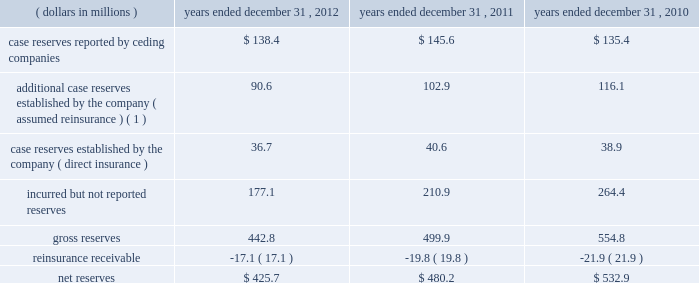The company endeavors to actively engage with every insured account posing significant potential asbestos exposure to mt .
Mckinley .
Such engagement can take the form of pursuing a final settlement , negotiation , litigation , or the monitoring of claim activity under settlement in place ( 201csip 201d ) agreements .
Sip agreements generally condition an insurer 2019s payment upon the actual claim experience of the insured and may have annual payment caps or other measures to control the insurer 2019s payments .
The company 2019s mt .
Mckinley operation is currently managing four sip agreements , one of which was executed prior to the acquisition of mt .
Mckinley in 2000 .
The company 2019s preference with respect to coverage settlements is to execute settlements that call for a fixed schedule of payments , because such settlements eliminate future uncertainty .
The company has significantly enhanced its classification of insureds by exposure characteristics over time , as well as its analysis by insured for those it considers to be more exposed or active .
Those insureds identified as relatively less exposed or active are subject to less rigorous , but still active management , with an emphasis on monitoring those characteristics , which may indicate an increasing exposure or levels of activity .
The company continually focuses on further enhancement of the detailed estimation processes used to evaluate potential exposure of policyholders .
Everest re 2019s book of assumed a&e reinsurance is relatively concentrated within a limited number of contracts and for a limited period , from 1974 to 1984 .
Because the book of business is relatively concentrated and the company has been managing the a&e exposures for many years , its claim staff is familiar with the ceding companies that have generated most of these liabilities in the past and which are therefore most likely to generate future liabilities .
The company 2019s claim staff has developed familiarity both with the nature of the business written by its ceding companies and the claims handling and reserving practices of those companies .
This level of familiarity enhances the quality of the company 2019s analysis of its exposure through those companies .
As a result , the company believes that it can identify those claims on which it has unusual exposure , such as non-products asbestos claims , for concentrated attention .
However , in setting reserves for its reinsurance liabilities , the company relies on claims data supplied , both formally and informally by its ceding companies and brokers .
This furnished information is not always timely or accurate and can impact the accuracy and timeliness of the company 2019s ultimate loss projections .
The table summarizes the composition of the company 2019s total reserves for a&e losses , gross and net of reinsurance , for the periods indicated: .
( 1 ) additional reserves are case specific reserves established by the company in excess of those reported by the ceding company , based on the company 2019s assessment of the covered loss .
( some amounts may not reconcile due to rounding. ) additional losses , including those relating to latent injuries and other exposures , which are as yet unrecognized , the type or magnitude of which cannot be foreseen by either the company or the industry , may emerge in the future .
Such future emergence could have material adverse effects on the company 2019s future financial condition , results of operations and cash flows. .
For the year ended december 312011 what was the percent of the incurred but not reported reserves as part of the total? 
Rationale: to get the percent you divide the amount by the total
Computations: (210.9 / 480.2)
Answer: 0.43919. The company endeavors to actively engage with every insured account posing significant potential asbestos exposure to mt .
Mckinley .
Such engagement can take the form of pursuing a final settlement , negotiation , litigation , or the monitoring of claim activity under settlement in place ( 201csip 201d ) agreements .
Sip agreements generally condition an insurer 2019s payment upon the actual claim experience of the insured and may have annual payment caps or other measures to control the insurer 2019s payments .
The company 2019s mt .
Mckinley operation is currently managing four sip agreements , one of which was executed prior to the acquisition of mt .
Mckinley in 2000 .
The company 2019s preference with respect to coverage settlements is to execute settlements that call for a fixed schedule of payments , because such settlements eliminate future uncertainty .
The company has significantly enhanced its classification of insureds by exposure characteristics over time , as well as its analysis by insured for those it considers to be more exposed or active .
Those insureds identified as relatively less exposed or active are subject to less rigorous , but still active management , with an emphasis on monitoring those characteristics , which may indicate an increasing exposure or levels of activity .
The company continually focuses on further enhancement of the detailed estimation processes used to evaluate potential exposure of policyholders .
Everest re 2019s book of assumed a&e reinsurance is relatively concentrated within a limited number of contracts and for a limited period , from 1974 to 1984 .
Because the book of business is relatively concentrated and the company has been managing the a&e exposures for many years , its claim staff is familiar with the ceding companies that have generated most of these liabilities in the past and which are therefore most likely to generate future liabilities .
The company 2019s claim staff has developed familiarity both with the nature of the business written by its ceding companies and the claims handling and reserving practices of those companies .
This level of familiarity enhances the quality of the company 2019s analysis of its exposure through those companies .
As a result , the company believes that it can identify those claims on which it has unusual exposure , such as non-products asbestos claims , for concentrated attention .
However , in setting reserves for its reinsurance liabilities , the company relies on claims data supplied , both formally and informally by its ceding companies and brokers .
This furnished information is not always timely or accurate and can impact the accuracy and timeliness of the company 2019s ultimate loss projections .
The table summarizes the composition of the company 2019s total reserves for a&e losses , gross and net of reinsurance , for the periods indicated: .
( 1 ) additional reserves are case specific reserves established by the company in excess of those reported by the ceding company , based on the company 2019s assessment of the covered loss .
( some amounts may not reconcile due to rounding. ) additional losses , including those relating to latent injuries and other exposures , which are as yet unrecognized , the type or magnitude of which cannot be foreseen by either the company or the industry , may emerge in the future .
Such future emergence could have material adverse effects on the company 2019s future financial condition , results of operations and cash flows. .
What is the percentage change in gross reserves from 2011 to 2012? 
Computations: ((442.8 - 499.9) / 499.9)
Answer: -0.11422. The company endeavors to actively engage with every insured account posing significant potential asbestos exposure to mt .
Mckinley .
Such engagement can take the form of pursuing a final settlement , negotiation , litigation , or the monitoring of claim activity under settlement in place ( 201csip 201d ) agreements .
Sip agreements generally condition an insurer 2019s payment upon the actual claim experience of the insured and may have annual payment caps or other measures to control the insurer 2019s payments .
The company 2019s mt .
Mckinley operation is currently managing four sip agreements , one of which was executed prior to the acquisition of mt .
Mckinley in 2000 .
The company 2019s preference with respect to coverage settlements is to execute settlements that call for a fixed schedule of payments , because such settlements eliminate future uncertainty .
The company has significantly enhanced its classification of insureds by exposure characteristics over time , as well as its analysis by insured for those it considers to be more exposed or active .
Those insureds identified as relatively less exposed or active are subject to less rigorous , but still active management , with an emphasis on monitoring those characteristics , which may indicate an increasing exposure or levels of activity .
The company continually focuses on further enhancement of the detailed estimation processes used to evaluate potential exposure of policyholders .
Everest re 2019s book of assumed a&e reinsurance is relatively concentrated within a limited number of contracts and for a limited period , from 1974 to 1984 .
Because the book of business is relatively concentrated and the company has been managing the a&e exposures for many years , its claim staff is familiar with the ceding companies that have generated most of these liabilities in the past and which are therefore most likely to generate future liabilities .
The company 2019s claim staff has developed familiarity both with the nature of the business written by its ceding companies and the claims handling and reserving practices of those companies .
This level of familiarity enhances the quality of the company 2019s analysis of its exposure through those companies .
As a result , the company believes that it can identify those claims on which it has unusual exposure , such as non-products asbestos claims , for concentrated attention .
However , in setting reserves for its reinsurance liabilities , the company relies on claims data supplied , both formally and informally by its ceding companies and brokers .
This furnished information is not always timely or accurate and can impact the accuracy and timeliness of the company 2019s ultimate loss projections .
The table summarizes the composition of the company 2019s total reserves for a&e losses , gross and net of reinsurance , for the periods indicated: .
( 1 ) additional reserves are case specific reserves established by the company in excess of those reported by the ceding company , based on the company 2019s assessment of the covered loss .
( some amounts may not reconcile due to rounding. ) additional losses , including those relating to latent injuries and other exposures , which are as yet unrecognized , the type or magnitude of which cannot be foreseen by either the company or the industry , may emerge in the future .
Such future emergence could have material adverse effects on the company 2019s future financial condition , results of operations and cash flows. .
What is the percentage change in net reserves from 2011 to 2012? 
Computations: ((425.7 - 480.2) / 480.2)
Answer: -0.11349. 